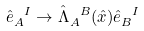Convert formula to latex. <formula><loc_0><loc_0><loc_500><loc_500>\hat { e } _ { A } ^ { \ I } \rightarrow \hat { \Lambda } _ { A } ^ { \ B } ( \hat { x } ) \hat { e } _ { B } ^ { \ I }</formula> 